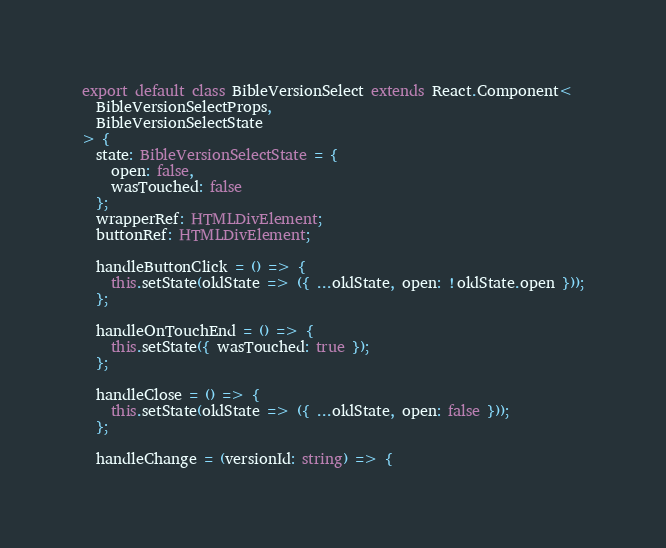Convert code to text. <code><loc_0><loc_0><loc_500><loc_500><_TypeScript_>
export default class BibleVersionSelect extends React.Component<
  BibleVersionSelectProps,
  BibleVersionSelectState
> {
  state: BibleVersionSelectState = {
    open: false,
    wasTouched: false
  };
  wrapperRef: HTMLDivElement;
  buttonRef: HTMLDivElement;

  handleButtonClick = () => {
    this.setState(oldState => ({ ...oldState, open: !oldState.open }));
  };

  handleOnTouchEnd = () => {
    this.setState({ wasTouched: true });
  };

  handleClose = () => {
    this.setState(oldState => ({ ...oldState, open: false }));
  };

  handleChange = (versionId: string) => {</code> 